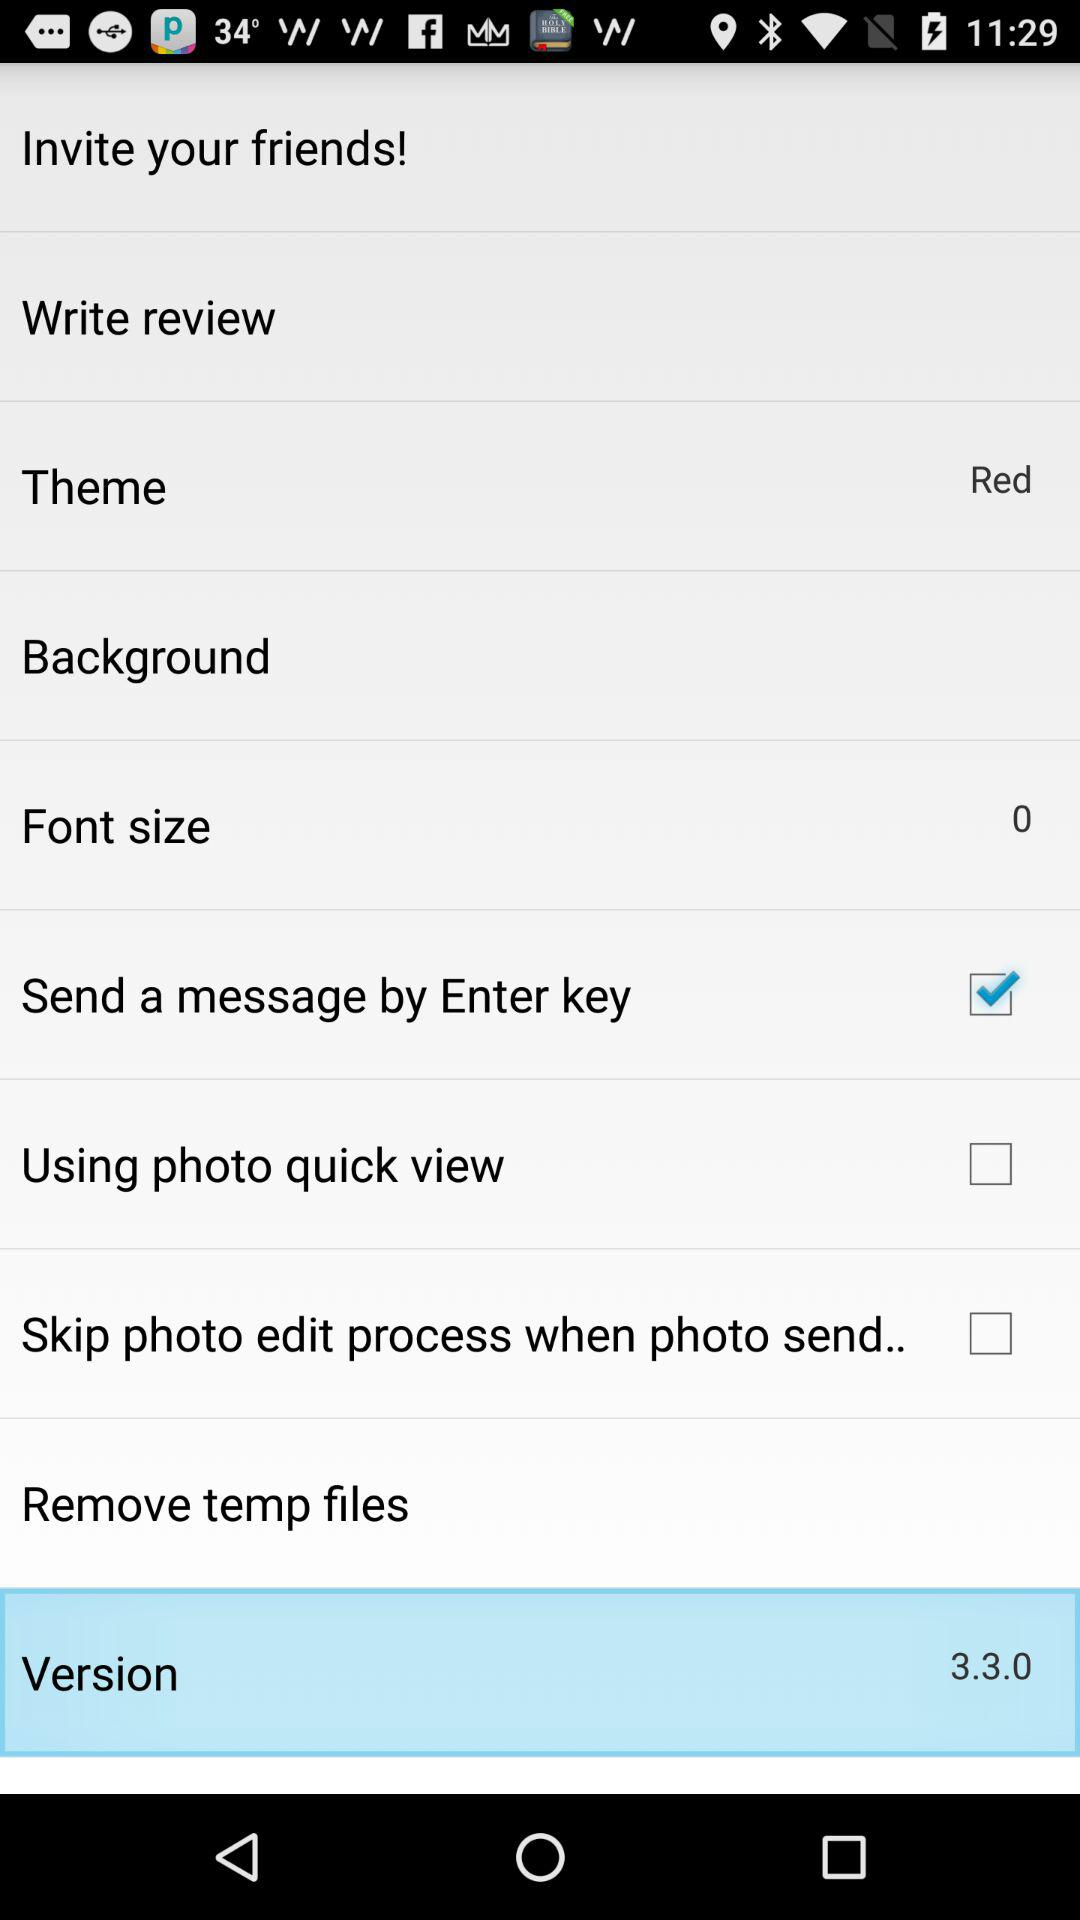What is the selected theme? The selected theme is red. 